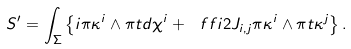Convert formula to latex. <formula><loc_0><loc_0><loc_500><loc_500>S ^ { \prime } = \int _ { \Sigma } \left \{ i \pi \kappa ^ { i } \wedge \pi t d \chi ^ { i } + \ f f { i } { 2 } J _ { i , j } \pi \kappa ^ { i } \wedge \pi t \kappa ^ { j } \right \} .</formula> 